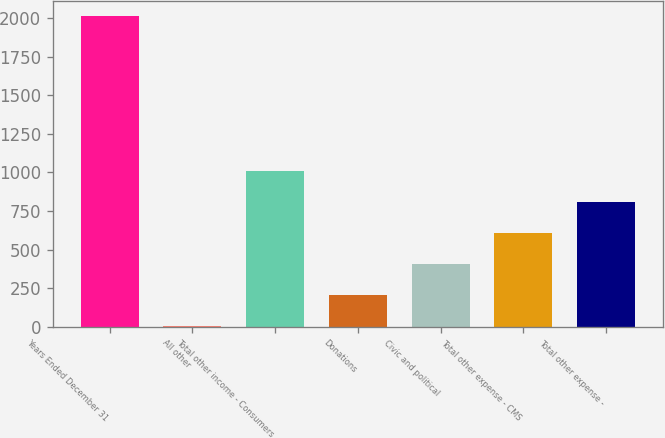Convert chart to OTSL. <chart><loc_0><loc_0><loc_500><loc_500><bar_chart><fcel>Years Ended December 31<fcel>All other<fcel>Total other income - Consumers<fcel>Donations<fcel>Civic and political<fcel>Total other expense - CMS<fcel>Total other expense -<nl><fcel>2015<fcel>1<fcel>1008<fcel>202.4<fcel>403.8<fcel>605.2<fcel>806.6<nl></chart> 